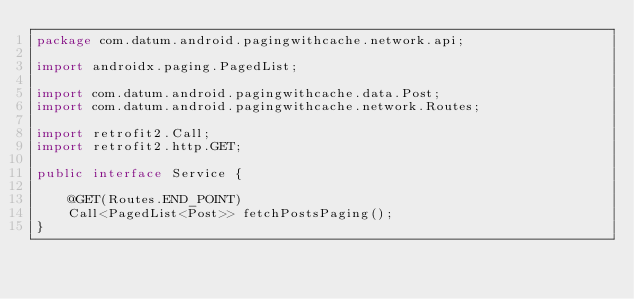Convert code to text. <code><loc_0><loc_0><loc_500><loc_500><_Java_>package com.datum.android.pagingwithcache.network.api;

import androidx.paging.PagedList;

import com.datum.android.pagingwithcache.data.Post;
import com.datum.android.pagingwithcache.network.Routes;

import retrofit2.Call;
import retrofit2.http.GET;

public interface Service {

    @GET(Routes.END_POINT)
    Call<PagedList<Post>> fetchPostsPaging();
}
</code> 